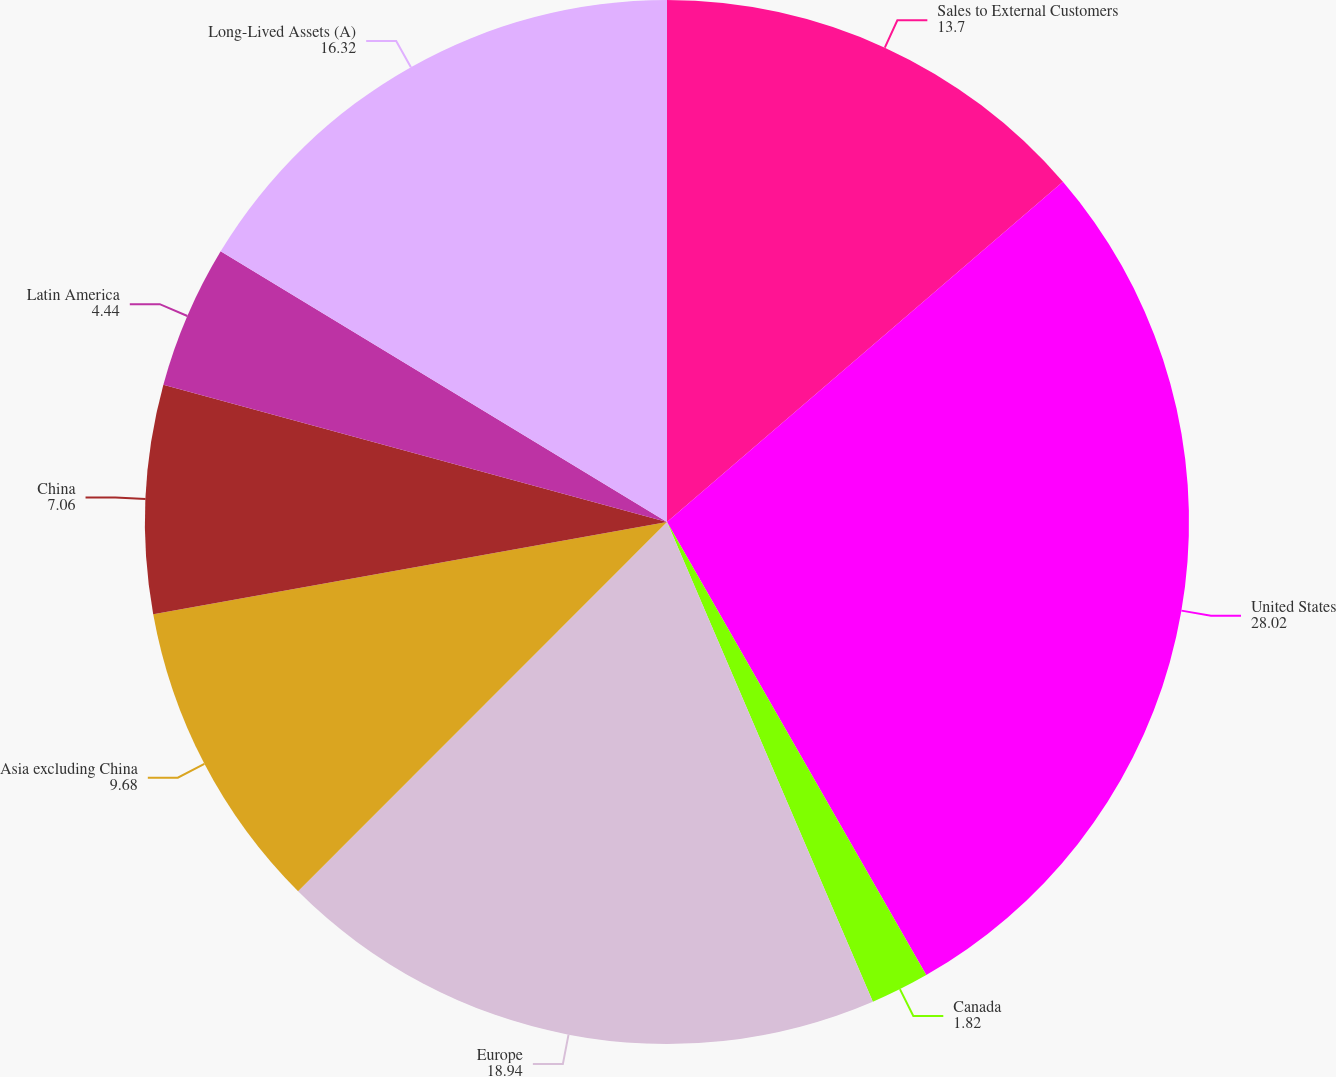Convert chart to OTSL. <chart><loc_0><loc_0><loc_500><loc_500><pie_chart><fcel>Sales to External Customers<fcel>United States<fcel>Canada<fcel>Europe<fcel>Asia excluding China<fcel>China<fcel>Latin America<fcel>Long-Lived Assets (A)<nl><fcel>13.7%<fcel>28.02%<fcel>1.82%<fcel>18.94%<fcel>9.68%<fcel>7.06%<fcel>4.44%<fcel>16.32%<nl></chart> 